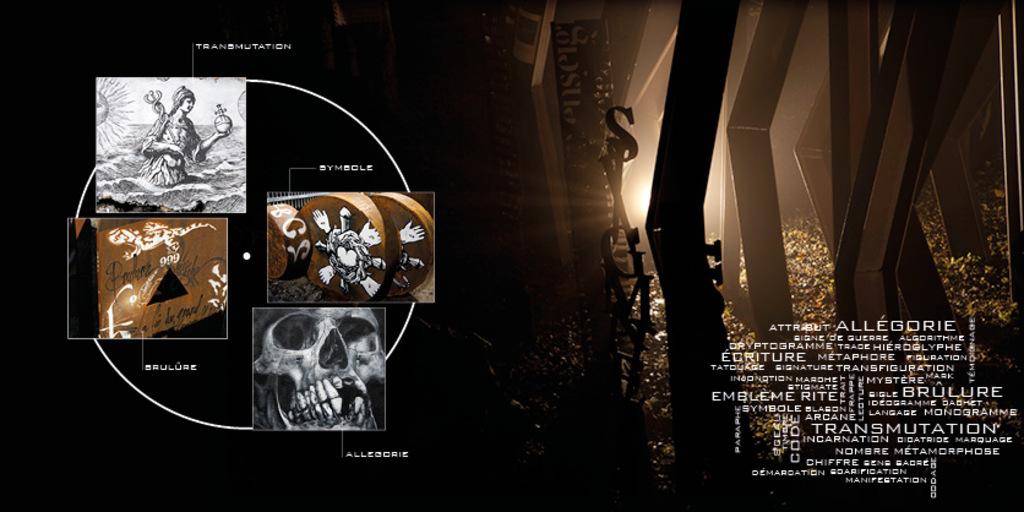What is one of the seemingly random words on this picture?
Offer a terse response. Unanswerable. What is written above the circle?
Make the answer very short. Transmutation. 